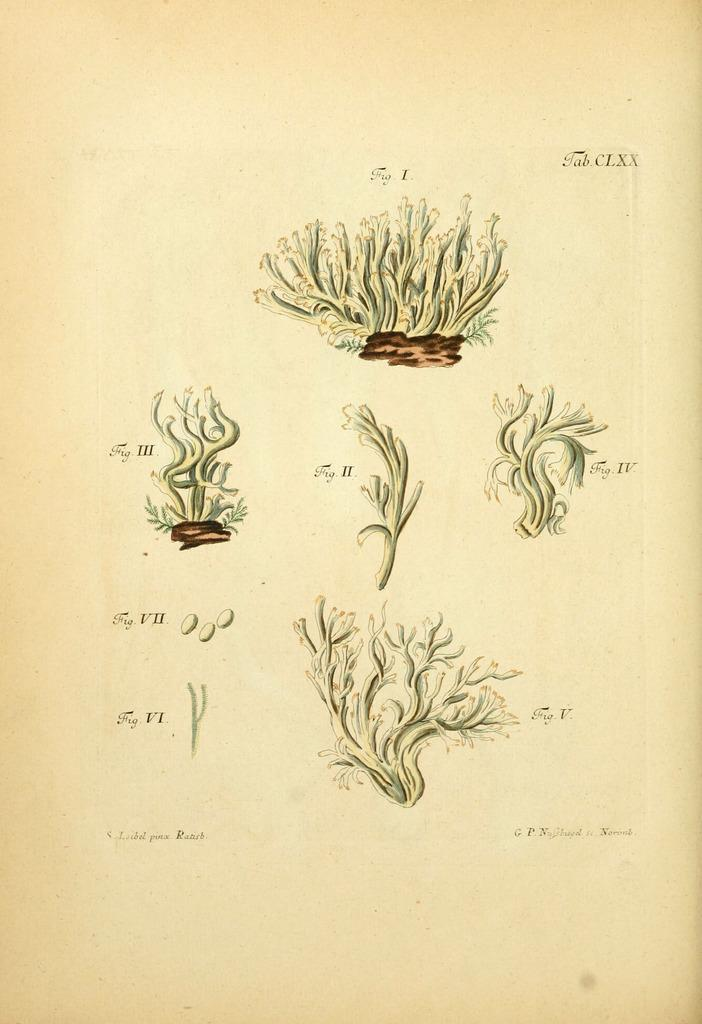What is depicted in the image? There is a drawing of plants in the image. What is the medium of the drawing? The drawing is on a paper. What type of bait is used to attract the plants in the image? There is no bait present in the image, as it is a drawing of plants on a paper. How many roots can be seen in the drawing of the plants? The image is a drawing of plants, not a photograph, so it does not show the actual roots of the plants. 